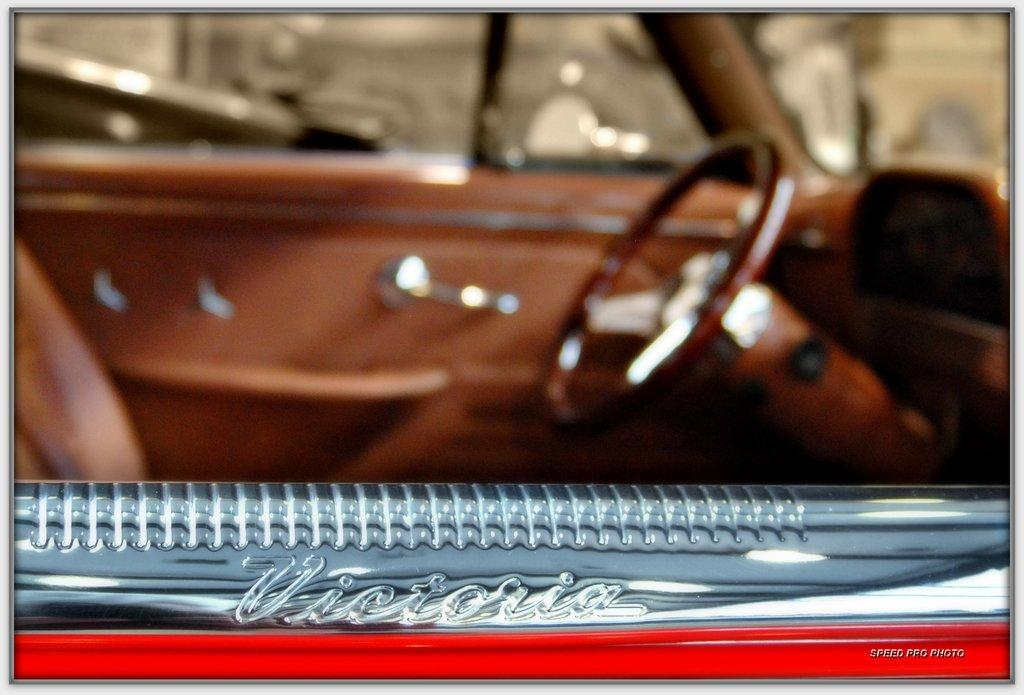What is the main subject of the image? The main subject of the image is a vehicle. Can you describe any specific features of the vehicle? Yes, there is text on the vehicle. What type of kettle is being used to fly the kite in the image? There is no kettle or kite present in the image; it only features a vehicle with text on it. 